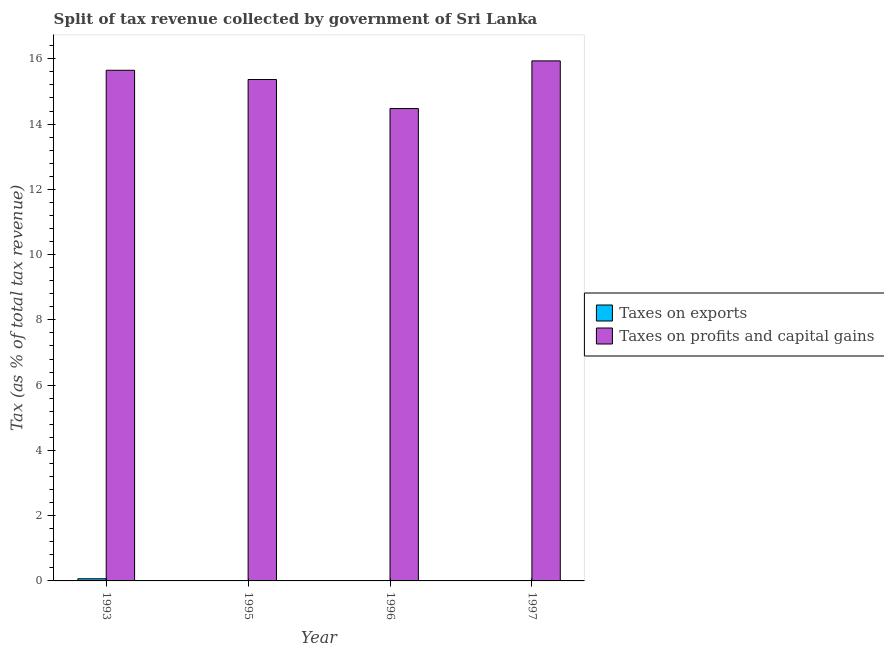How many groups of bars are there?
Keep it short and to the point. 4. Are the number of bars per tick equal to the number of legend labels?
Give a very brief answer. Yes. Are the number of bars on each tick of the X-axis equal?
Offer a very short reply. Yes. How many bars are there on the 2nd tick from the right?
Your response must be concise. 2. What is the percentage of revenue obtained from taxes on profits and capital gains in 1996?
Provide a short and direct response. 14.48. Across all years, what is the maximum percentage of revenue obtained from taxes on exports?
Make the answer very short. 0.07. Across all years, what is the minimum percentage of revenue obtained from taxes on exports?
Give a very brief answer. 0. In which year was the percentage of revenue obtained from taxes on profits and capital gains minimum?
Ensure brevity in your answer.  1996. What is the total percentage of revenue obtained from taxes on profits and capital gains in the graph?
Provide a succinct answer. 61.43. What is the difference between the percentage of revenue obtained from taxes on profits and capital gains in 1993 and that in 1995?
Ensure brevity in your answer.  0.28. What is the difference between the percentage of revenue obtained from taxes on profits and capital gains in 1995 and the percentage of revenue obtained from taxes on exports in 1997?
Your answer should be very brief. -0.57. What is the average percentage of revenue obtained from taxes on profits and capital gains per year?
Give a very brief answer. 15.36. What is the ratio of the percentage of revenue obtained from taxes on profits and capital gains in 1995 to that in 1997?
Ensure brevity in your answer.  0.96. Is the percentage of revenue obtained from taxes on exports in 1995 less than that in 1997?
Keep it short and to the point. No. What is the difference between the highest and the second highest percentage of revenue obtained from taxes on exports?
Ensure brevity in your answer.  0.06. What is the difference between the highest and the lowest percentage of revenue obtained from taxes on exports?
Provide a short and direct response. 0.06. Is the sum of the percentage of revenue obtained from taxes on profits and capital gains in 1996 and 1997 greater than the maximum percentage of revenue obtained from taxes on exports across all years?
Offer a terse response. Yes. What does the 1st bar from the left in 1997 represents?
Ensure brevity in your answer.  Taxes on exports. What does the 1st bar from the right in 1993 represents?
Offer a terse response. Taxes on profits and capital gains. Are all the bars in the graph horizontal?
Provide a short and direct response. No. Does the graph contain any zero values?
Your answer should be very brief. No. Does the graph contain grids?
Your response must be concise. No. Where does the legend appear in the graph?
Provide a short and direct response. Center right. How many legend labels are there?
Your response must be concise. 2. What is the title of the graph?
Your answer should be very brief. Split of tax revenue collected by government of Sri Lanka. Does "Attending school" appear as one of the legend labels in the graph?
Keep it short and to the point. No. What is the label or title of the Y-axis?
Provide a succinct answer. Tax (as % of total tax revenue). What is the Tax (as % of total tax revenue) in Taxes on exports in 1993?
Give a very brief answer. 0.07. What is the Tax (as % of total tax revenue) in Taxes on profits and capital gains in 1993?
Your answer should be very brief. 15.65. What is the Tax (as % of total tax revenue) of Taxes on exports in 1995?
Your answer should be compact. 0.01. What is the Tax (as % of total tax revenue) in Taxes on profits and capital gains in 1995?
Provide a short and direct response. 15.37. What is the Tax (as % of total tax revenue) of Taxes on exports in 1996?
Make the answer very short. 0. What is the Tax (as % of total tax revenue) in Taxes on profits and capital gains in 1996?
Provide a short and direct response. 14.48. What is the Tax (as % of total tax revenue) of Taxes on exports in 1997?
Your response must be concise. 0. What is the Tax (as % of total tax revenue) in Taxes on profits and capital gains in 1997?
Your response must be concise. 15.94. Across all years, what is the maximum Tax (as % of total tax revenue) of Taxes on exports?
Give a very brief answer. 0.07. Across all years, what is the maximum Tax (as % of total tax revenue) of Taxes on profits and capital gains?
Your response must be concise. 15.94. Across all years, what is the minimum Tax (as % of total tax revenue) in Taxes on exports?
Make the answer very short. 0. Across all years, what is the minimum Tax (as % of total tax revenue) in Taxes on profits and capital gains?
Provide a short and direct response. 14.48. What is the total Tax (as % of total tax revenue) of Taxes on exports in the graph?
Give a very brief answer. 0.08. What is the total Tax (as % of total tax revenue) of Taxes on profits and capital gains in the graph?
Give a very brief answer. 61.43. What is the difference between the Tax (as % of total tax revenue) in Taxes on exports in 1993 and that in 1995?
Provide a succinct answer. 0.06. What is the difference between the Tax (as % of total tax revenue) in Taxes on profits and capital gains in 1993 and that in 1995?
Provide a succinct answer. 0.28. What is the difference between the Tax (as % of total tax revenue) in Taxes on exports in 1993 and that in 1996?
Your answer should be very brief. 0.06. What is the difference between the Tax (as % of total tax revenue) in Taxes on profits and capital gains in 1993 and that in 1996?
Give a very brief answer. 1.17. What is the difference between the Tax (as % of total tax revenue) of Taxes on exports in 1993 and that in 1997?
Offer a very short reply. 0.06. What is the difference between the Tax (as % of total tax revenue) of Taxes on profits and capital gains in 1993 and that in 1997?
Make the answer very short. -0.29. What is the difference between the Tax (as % of total tax revenue) in Taxes on exports in 1995 and that in 1996?
Keep it short and to the point. 0. What is the difference between the Tax (as % of total tax revenue) of Taxes on profits and capital gains in 1995 and that in 1996?
Keep it short and to the point. 0.89. What is the difference between the Tax (as % of total tax revenue) of Taxes on exports in 1995 and that in 1997?
Provide a short and direct response. 0. What is the difference between the Tax (as % of total tax revenue) in Taxes on profits and capital gains in 1995 and that in 1997?
Offer a terse response. -0.57. What is the difference between the Tax (as % of total tax revenue) of Taxes on exports in 1996 and that in 1997?
Your answer should be very brief. 0. What is the difference between the Tax (as % of total tax revenue) of Taxes on profits and capital gains in 1996 and that in 1997?
Provide a succinct answer. -1.46. What is the difference between the Tax (as % of total tax revenue) in Taxes on exports in 1993 and the Tax (as % of total tax revenue) in Taxes on profits and capital gains in 1995?
Make the answer very short. -15.3. What is the difference between the Tax (as % of total tax revenue) of Taxes on exports in 1993 and the Tax (as % of total tax revenue) of Taxes on profits and capital gains in 1996?
Give a very brief answer. -14.41. What is the difference between the Tax (as % of total tax revenue) in Taxes on exports in 1993 and the Tax (as % of total tax revenue) in Taxes on profits and capital gains in 1997?
Give a very brief answer. -15.87. What is the difference between the Tax (as % of total tax revenue) of Taxes on exports in 1995 and the Tax (as % of total tax revenue) of Taxes on profits and capital gains in 1996?
Provide a short and direct response. -14.47. What is the difference between the Tax (as % of total tax revenue) in Taxes on exports in 1995 and the Tax (as % of total tax revenue) in Taxes on profits and capital gains in 1997?
Keep it short and to the point. -15.93. What is the difference between the Tax (as % of total tax revenue) in Taxes on exports in 1996 and the Tax (as % of total tax revenue) in Taxes on profits and capital gains in 1997?
Provide a short and direct response. -15.93. What is the average Tax (as % of total tax revenue) in Taxes on exports per year?
Your response must be concise. 0.02. What is the average Tax (as % of total tax revenue) of Taxes on profits and capital gains per year?
Make the answer very short. 15.36. In the year 1993, what is the difference between the Tax (as % of total tax revenue) of Taxes on exports and Tax (as % of total tax revenue) of Taxes on profits and capital gains?
Ensure brevity in your answer.  -15.58. In the year 1995, what is the difference between the Tax (as % of total tax revenue) of Taxes on exports and Tax (as % of total tax revenue) of Taxes on profits and capital gains?
Make the answer very short. -15.36. In the year 1996, what is the difference between the Tax (as % of total tax revenue) of Taxes on exports and Tax (as % of total tax revenue) of Taxes on profits and capital gains?
Your response must be concise. -14.47. In the year 1997, what is the difference between the Tax (as % of total tax revenue) of Taxes on exports and Tax (as % of total tax revenue) of Taxes on profits and capital gains?
Provide a short and direct response. -15.93. What is the ratio of the Tax (as % of total tax revenue) of Taxes on exports in 1993 to that in 1995?
Offer a very short reply. 9.68. What is the ratio of the Tax (as % of total tax revenue) in Taxes on profits and capital gains in 1993 to that in 1995?
Ensure brevity in your answer.  1.02. What is the ratio of the Tax (as % of total tax revenue) of Taxes on exports in 1993 to that in 1996?
Your answer should be very brief. 17.01. What is the ratio of the Tax (as % of total tax revenue) in Taxes on profits and capital gains in 1993 to that in 1996?
Provide a succinct answer. 1.08. What is the ratio of the Tax (as % of total tax revenue) of Taxes on exports in 1993 to that in 1997?
Your answer should be compact. 23.27. What is the ratio of the Tax (as % of total tax revenue) of Taxes on profits and capital gains in 1993 to that in 1997?
Your answer should be compact. 0.98. What is the ratio of the Tax (as % of total tax revenue) of Taxes on exports in 1995 to that in 1996?
Give a very brief answer. 1.76. What is the ratio of the Tax (as % of total tax revenue) of Taxes on profits and capital gains in 1995 to that in 1996?
Make the answer very short. 1.06. What is the ratio of the Tax (as % of total tax revenue) in Taxes on exports in 1995 to that in 1997?
Keep it short and to the point. 2.4. What is the ratio of the Tax (as % of total tax revenue) of Taxes on profits and capital gains in 1995 to that in 1997?
Your response must be concise. 0.96. What is the ratio of the Tax (as % of total tax revenue) of Taxes on exports in 1996 to that in 1997?
Your answer should be compact. 1.37. What is the ratio of the Tax (as % of total tax revenue) of Taxes on profits and capital gains in 1996 to that in 1997?
Make the answer very short. 0.91. What is the difference between the highest and the second highest Tax (as % of total tax revenue) in Taxes on exports?
Give a very brief answer. 0.06. What is the difference between the highest and the second highest Tax (as % of total tax revenue) in Taxes on profits and capital gains?
Your answer should be very brief. 0.29. What is the difference between the highest and the lowest Tax (as % of total tax revenue) of Taxes on exports?
Make the answer very short. 0.06. What is the difference between the highest and the lowest Tax (as % of total tax revenue) in Taxes on profits and capital gains?
Offer a terse response. 1.46. 